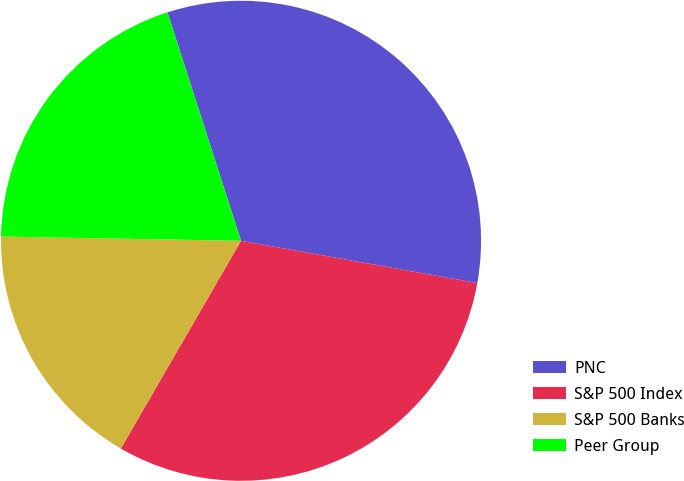Convert chart to OTSL. <chart><loc_0><loc_0><loc_500><loc_500><pie_chart><fcel>PNC<fcel>S&P 500 Index<fcel>S&P 500 Banks<fcel>Peer Group<nl><fcel>32.78%<fcel>30.53%<fcel>16.93%<fcel>19.76%<nl></chart> 